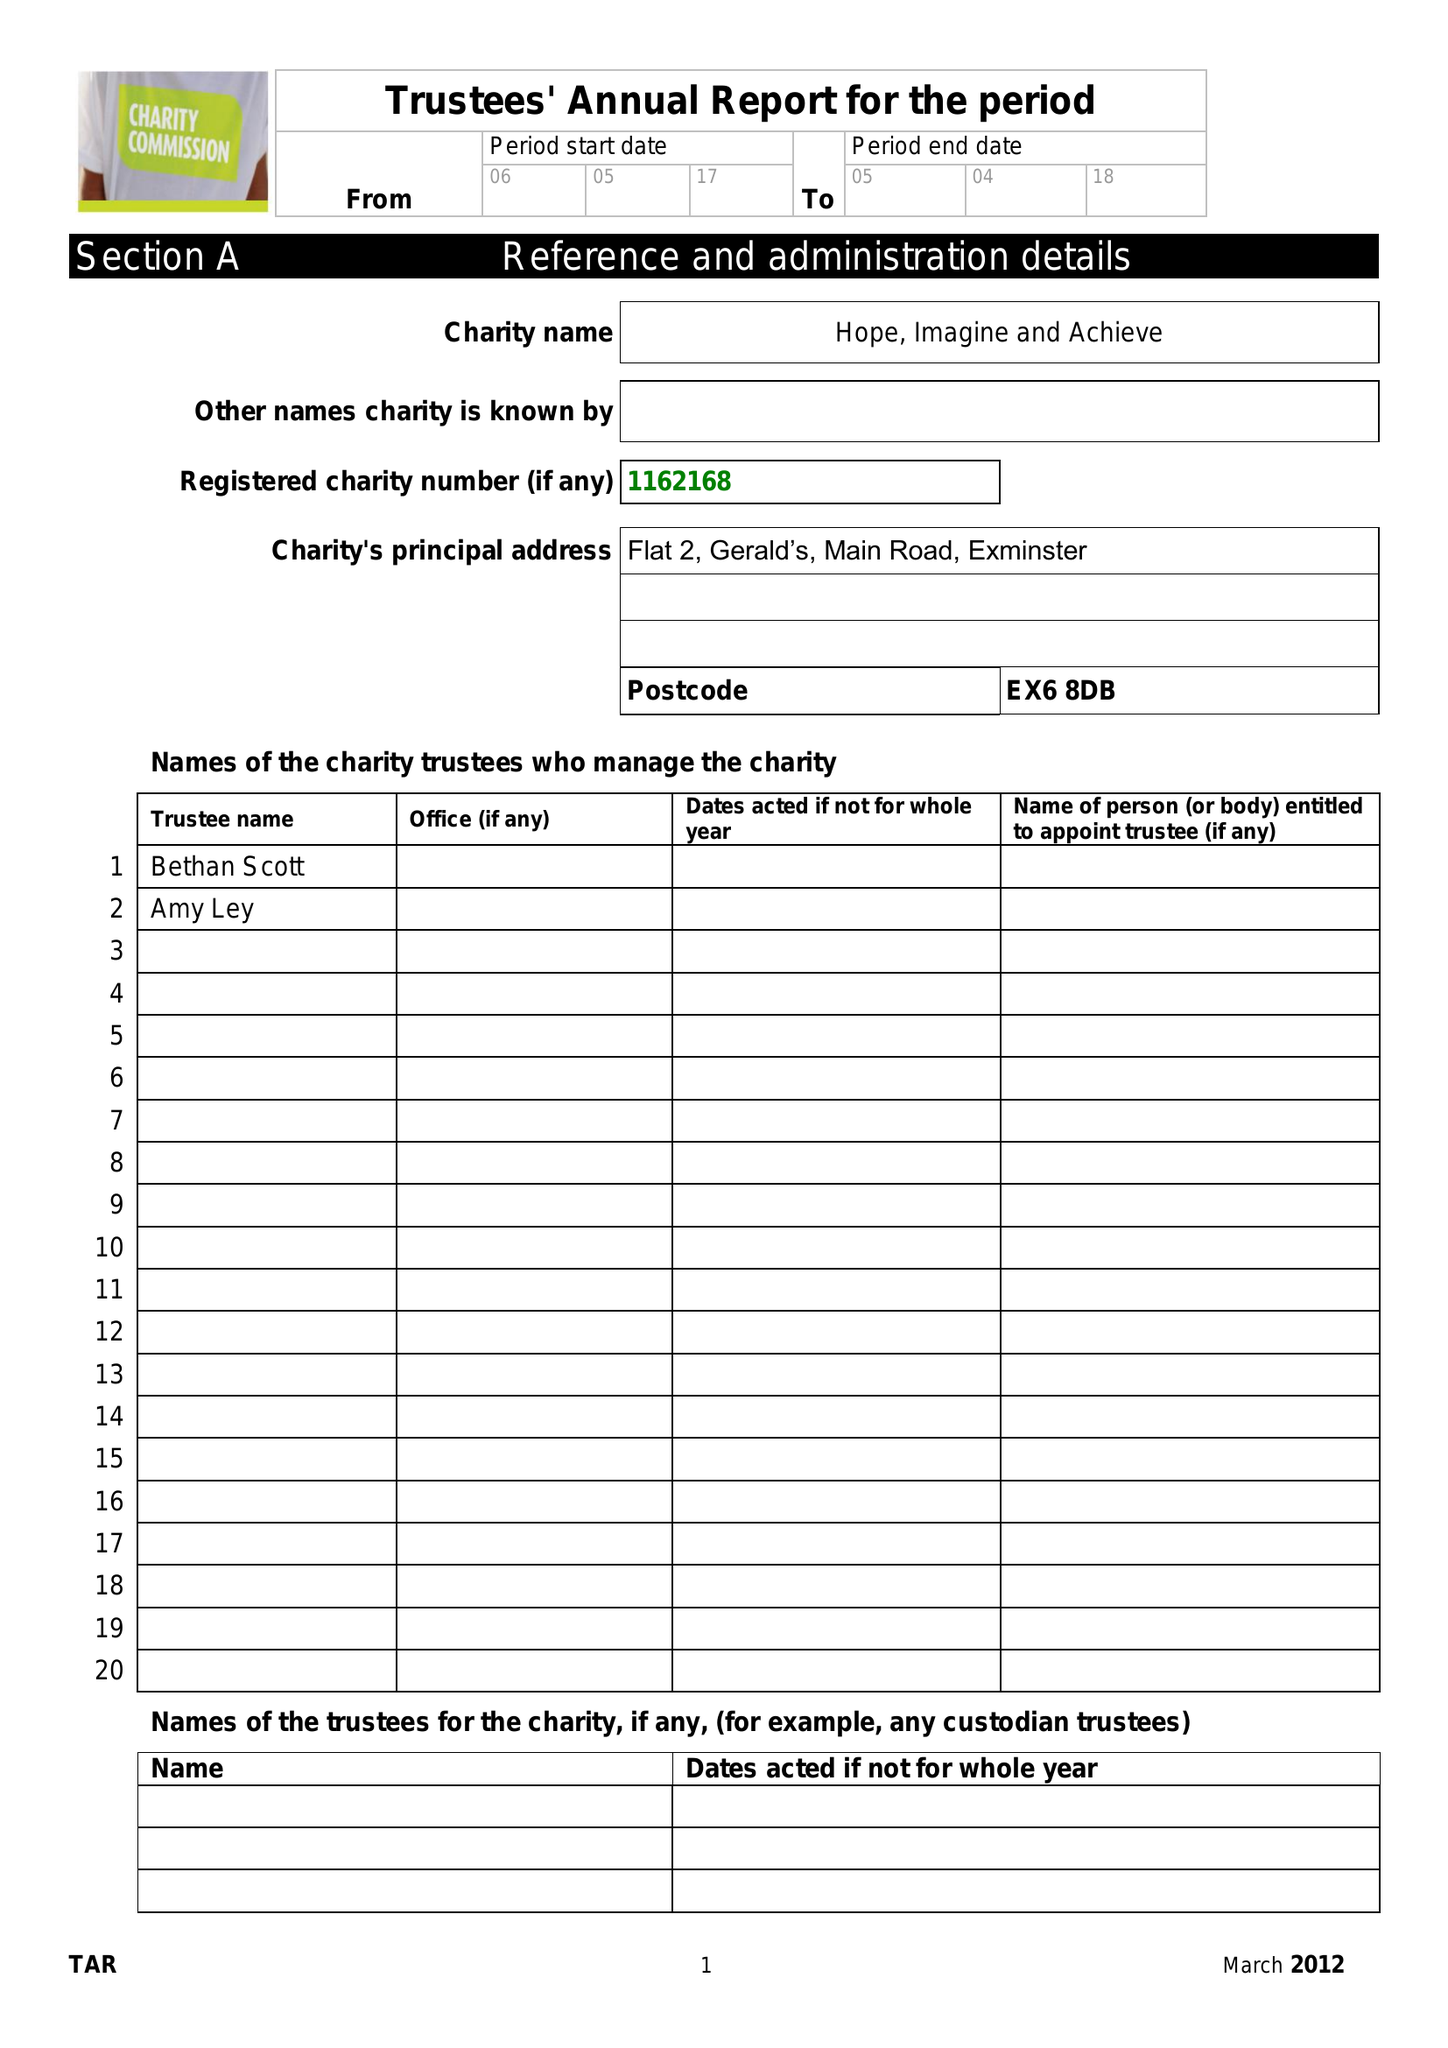What is the value for the address__street_line?
Answer the question using a single word or phrase. None 